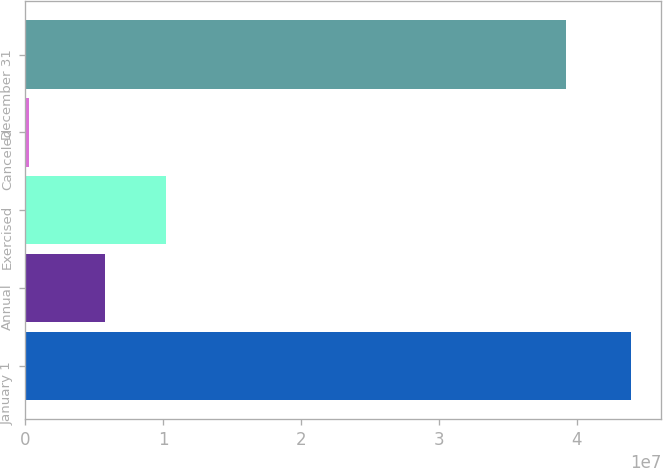Convert chart to OTSL. <chart><loc_0><loc_0><loc_500><loc_500><bar_chart><fcel>January 1<fcel>Annual<fcel>Exercised<fcel>Canceled<fcel>December 31<nl><fcel>4.39388e+07<fcel>5.73618e+06<fcel>1.02193e+07<fcel>220143<fcel>3.92356e+07<nl></chart> 